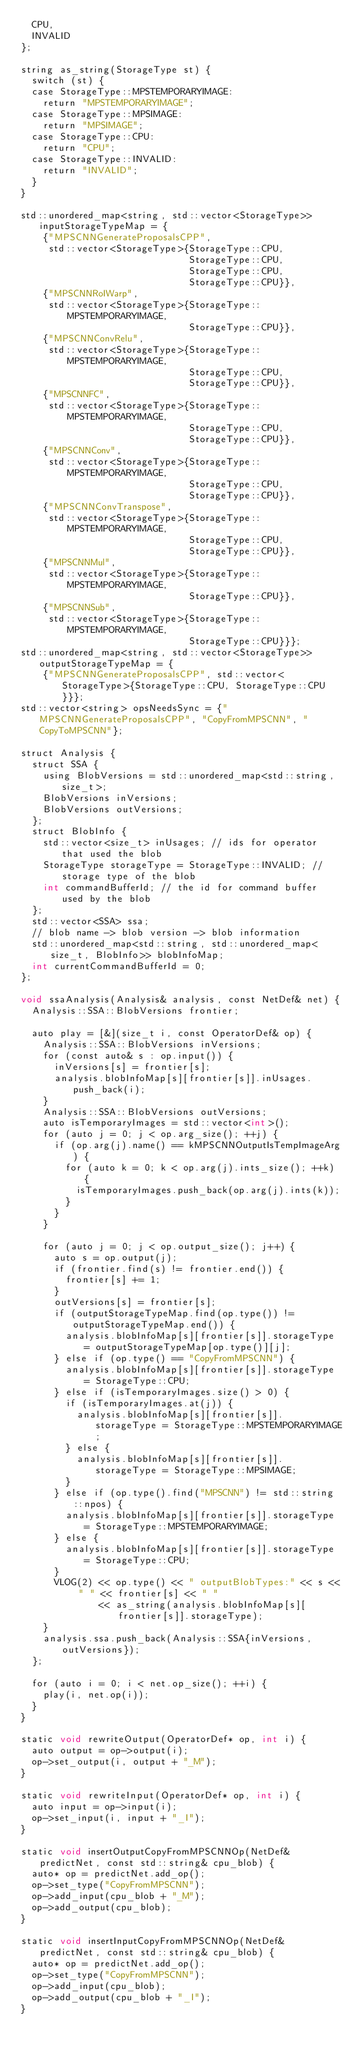<code> <loc_0><loc_0><loc_500><loc_500><_ObjectiveC_>  CPU,
  INVALID
};

string as_string(StorageType st) {
  switch (st) {
  case StorageType::MPSTEMPORARYIMAGE:
    return "MPSTEMPORARYIMAGE";
  case StorageType::MPSIMAGE:
    return "MPSIMAGE";
  case StorageType::CPU:
    return "CPU";
  case StorageType::INVALID:
    return "INVALID";
  }
}

std::unordered_map<string, std::vector<StorageType>> inputStorageTypeMap = {
    {"MPSCNNGenerateProposalsCPP",
     std::vector<StorageType>{StorageType::CPU,
                              StorageType::CPU,
                              StorageType::CPU,
                              StorageType::CPU}},
    {"MPSCNNRoIWarp",
     std::vector<StorageType>{StorageType::MPSTEMPORARYIMAGE,
                              StorageType::CPU}},
    {"MPSCNNConvRelu",
     std::vector<StorageType>{StorageType::MPSTEMPORARYIMAGE,
                              StorageType::CPU,
                              StorageType::CPU}},
    {"MPSCNNFC",
     std::vector<StorageType>{StorageType::MPSTEMPORARYIMAGE,
                              StorageType::CPU,
                              StorageType::CPU}},
    {"MPSCNNConv",
     std::vector<StorageType>{StorageType::MPSTEMPORARYIMAGE,
                              StorageType::CPU,
                              StorageType::CPU}},
    {"MPSCNNConvTranspose",
     std::vector<StorageType>{StorageType::MPSTEMPORARYIMAGE,
                              StorageType::CPU,
                              StorageType::CPU}},
    {"MPSCNNMul",
     std::vector<StorageType>{StorageType::MPSTEMPORARYIMAGE,
                              StorageType::CPU}},
    {"MPSCNNSub",
     std::vector<StorageType>{StorageType::MPSTEMPORARYIMAGE,
                              StorageType::CPU}}};
std::unordered_map<string, std::vector<StorageType>> outputStorageTypeMap = {
    {"MPSCNNGenerateProposalsCPP", std::vector<StorageType>{StorageType::CPU, StorageType::CPU}}};
std::vector<string> opsNeedsSync = {"MPSCNNGenerateProposalsCPP", "CopyFromMPSCNN", "CopyToMPSCNN"};

struct Analysis {
  struct SSA {
    using BlobVersions = std::unordered_map<std::string, size_t>;
    BlobVersions inVersions;
    BlobVersions outVersions;
  };
  struct BlobInfo {
    std::vector<size_t> inUsages; // ids for operator that used the blob
    StorageType storageType = StorageType::INVALID; // storage type of the blob
    int commandBufferId; // the id for command buffer used by the blob
  };
  std::vector<SSA> ssa;
  // blob name -> blob version -> blob information
  std::unordered_map<std::string, std::unordered_map<size_t, BlobInfo>> blobInfoMap;
  int currentCommandBufferId = 0;
};

void ssaAnalysis(Analysis& analysis, const NetDef& net) {
  Analysis::SSA::BlobVersions frontier;

  auto play = [&](size_t i, const OperatorDef& op) {
    Analysis::SSA::BlobVersions inVersions;
    for (const auto& s : op.input()) {
      inVersions[s] = frontier[s];
      analysis.blobInfoMap[s][frontier[s]].inUsages.push_back(i);
    }
    Analysis::SSA::BlobVersions outVersions;
    auto isTemporaryImages = std::vector<int>();
    for (auto j = 0; j < op.arg_size(); ++j) {
      if (op.arg(j).name() == kMPSCNNOutputIsTempImageArg) {
        for (auto k = 0; k < op.arg(j).ints_size(); ++k) {
          isTemporaryImages.push_back(op.arg(j).ints(k));
        }
      }
    }

    for (auto j = 0; j < op.output_size(); j++) {
      auto s = op.output(j);
      if (frontier.find(s) != frontier.end()) {
        frontier[s] += 1;
      }
      outVersions[s] = frontier[s];
      if (outputStorageTypeMap.find(op.type()) != outputStorageTypeMap.end()) {
        analysis.blobInfoMap[s][frontier[s]].storageType = outputStorageTypeMap[op.type()][j];
      } else if (op.type() == "CopyFromMPSCNN") {
        analysis.blobInfoMap[s][frontier[s]].storageType = StorageType::CPU;
      } else if (isTemporaryImages.size() > 0) {
        if (isTemporaryImages.at(j)) {
          analysis.blobInfoMap[s][frontier[s]].storageType = StorageType::MPSTEMPORARYIMAGE;
        } else {
          analysis.blobInfoMap[s][frontier[s]].storageType = StorageType::MPSIMAGE;
        }
      } else if (op.type().find("MPSCNN") != std::string::npos) {
        analysis.blobInfoMap[s][frontier[s]].storageType = StorageType::MPSTEMPORARYIMAGE;
      } else {
        analysis.blobInfoMap[s][frontier[s]].storageType = StorageType::CPU;
      }
      VLOG(2) << op.type() << " outputBlobTypes:" << s << " " << frontier[s] << " "
              << as_string(analysis.blobInfoMap[s][frontier[s]].storageType);
    }
    analysis.ssa.push_back(Analysis::SSA{inVersions, outVersions});
  };

  for (auto i = 0; i < net.op_size(); ++i) {
    play(i, net.op(i));
  }
}

static void rewriteOutput(OperatorDef* op, int i) {
  auto output = op->output(i);
  op->set_output(i, output + "_M");
}

static void rewriteInput(OperatorDef* op, int i) {
  auto input = op->input(i);
  op->set_input(i, input + "_I");
}

static void insertOutputCopyFromMPSCNNOp(NetDef& predictNet, const std::string& cpu_blob) {
  auto* op = predictNet.add_op();
  op->set_type("CopyFromMPSCNN");
  op->add_input(cpu_blob + "_M");
  op->add_output(cpu_blob);
}

static void insertInputCopyFromMPSCNNOp(NetDef& predictNet, const std::string& cpu_blob) {
  auto* op = predictNet.add_op();
  op->set_type("CopyFromMPSCNN");
  op->add_input(cpu_blob);
  op->add_output(cpu_blob + "_I");
}
</code> 